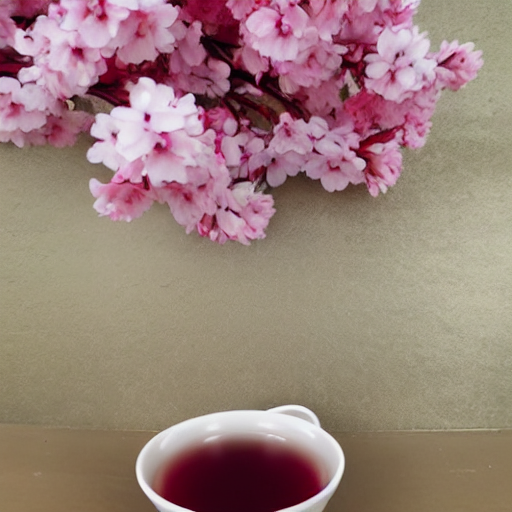Could you tell me more about the choice of colors in this composition? Certainly. The image features a soft, almost pastel color palette that creates a calming, harmonious atmosphere. The interplay of the pink hues of the cherry blossoms with the dark tone of the tea and the neutral background emphasizes a natural and minimalist aesthetic. What mood does this setting evoke? This setting evokes a sense of tranquility and gentle reflection. It might be designed to inspire one to take a quiet moment to enjoy simple pleasures, like the beauty of blossoms or the taste of a warm cup of tea, encouraging mindfulness and contentment. 